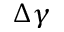<formula> <loc_0><loc_0><loc_500><loc_500>\Delta \gamma</formula> 